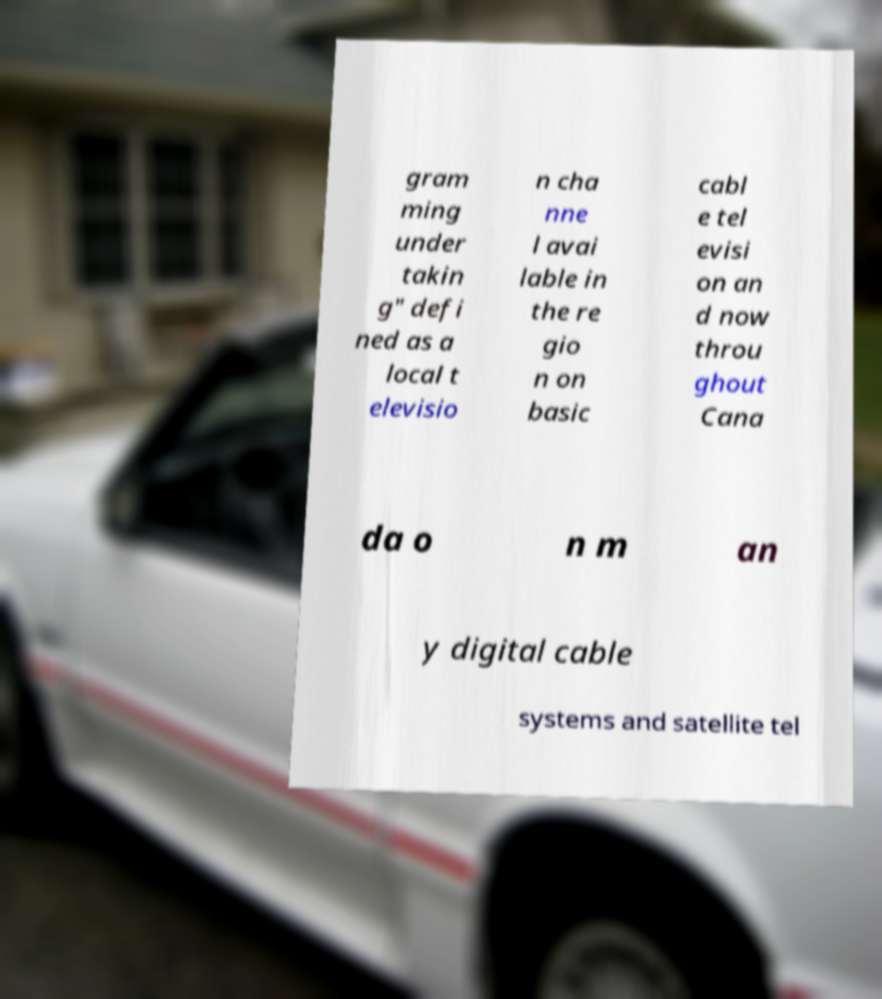Can you accurately transcribe the text from the provided image for me? gram ming under takin g" defi ned as a local t elevisio n cha nne l avai lable in the re gio n on basic cabl e tel evisi on an d now throu ghout Cana da o n m an y digital cable systems and satellite tel 